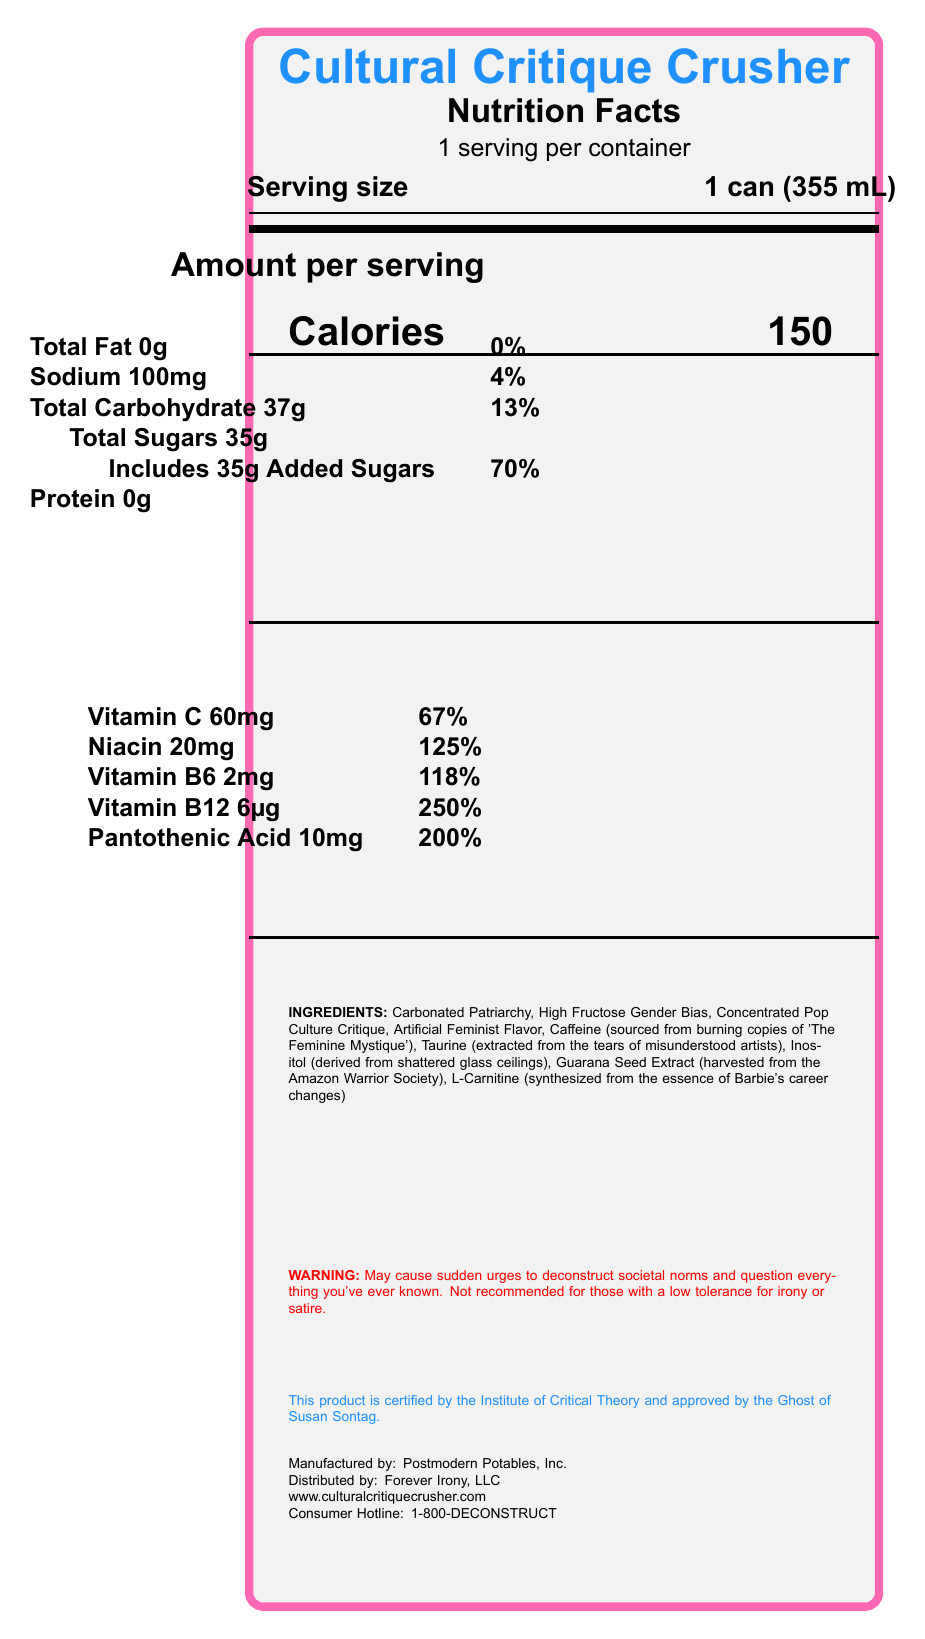what is the serving size? The serving size is clearly stated as "1 can (355 mL)" in the document.
Answer: 1 can (355 mL) how many calories are in one serving? The document lists the calories per serving as 150.
Answer: 150 what is the daily value percentage of added sugars? The document specifies that the daily value percentage of added sugars is 70%.
Answer: 70% name three satirical ingredients listed in the document These three ingredients are listed under "INGREDIENTS" in the document.
Answer: Carbonated Patriarchy, High Fructose Gender Bias, Concentrated Pop Culture Critique what is the main vitamin present in the drink, and what percentage of the daily value does it cover? Vitamin B12 is listed with a daily value of 250%, which is the highest percentage among the vitamins listed.
Answer: Vitamin B12, 250% which bolded ingredient is derived from Barbie’s career changes? A. Taurine B. Inositol C. L-Carnitine D. Guarana Seed Extract The document specifies that L-Carnitine is "synthesized from the essence of Barbie's career changes."
Answer: C. L-Carnitine what is the amount of sodium in one serving? The document lists the sodium content as 100mg per serving.
Answer: 100mg which statement is true about the daily value of niacin in the drink? A. It provides 100% of the daily value. B. It provides 125% of the daily value. C. It provides 50% of the daily value. The document lists the daily value of niacin as 125%.
Answer: B. It provides 125% of the daily value. is there any total fat in the drink? The document specifies that the total fat content is 0g, meaning there is no fat.
Answer: No does the drink contain more carbohydrates or more proteins? The drink contains 37g of carbohydrates and 0g of protein, so it contains more carbohydrates.
Answer: Carbohydrates summarize the main idea of the document The document outlines all nutritional components of the energy drink alongside its satirical elements, emphasizing its cultural critique theme.
Answer: The document provides a detailed Nutrition Facts label for a satirical energy drink called "Cultural Critique Crusher." It lists the serving size, calorie content, and various nutrients such as vitamins, along with their daily values. The label also includes humorous, satirical ingredients and warnings related to social and cultural themes. what is the source of caffeine in the drink? The document humorously notes that the caffeine is sourced from burning copies of 'The Feminine Mystique.'
Answer: Burning copies of 'The Feminine Mystique' is this product recommended for those with a low tolerance for irony? The warning explicitly states that the product is "not recommended for those with a low tolerance for irony or satire."
Answer: No who manufactures the Cultural Critique Crusher? The document clearly mentions that the drink is manufactured by Postmodern Potables, Inc.
Answer: Postmodern Potables, Inc. how many servings are there per container? The document specifies that there is 1 serving per container.
Answer: 1 how much Vitamin C does one serving of the drink provide? The document lists 60mg of Vitamin C per serving.
Answer: 60mg how many calories does one can of Cultural Critique Crusher provide? The document states that one can (one serving) provides 150 calories.
Answer: 150 what is the consumer hotline number for Cultural Critique Crusher? The document lists the consumer hotline number as 1-800-DECONSTRUCT.
Answer: 1-800-DECONSTRUCT who approves this product, according to the document? The document humorously states that the product is "approved by the Ghost of Susan Sontag."
Answer: The Ghost of Susan Sontag does the drink contain any dietary fiber? The document does not provide any information regarding dietary fiber content.
Answer: Cannot be determined 